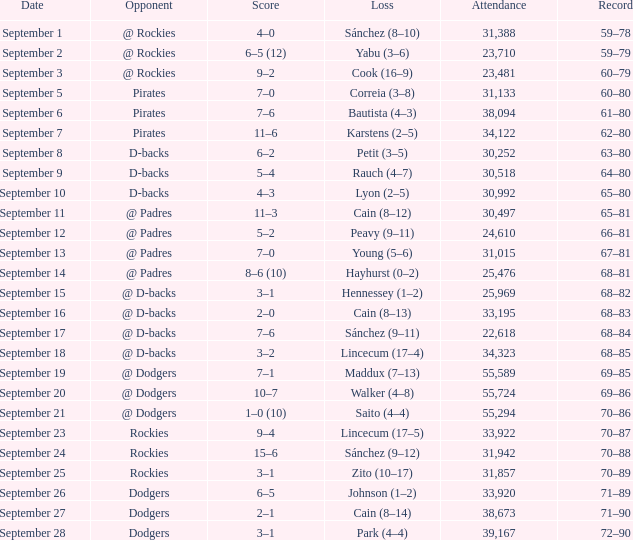What was the turnout on september 28? 39167.0. 